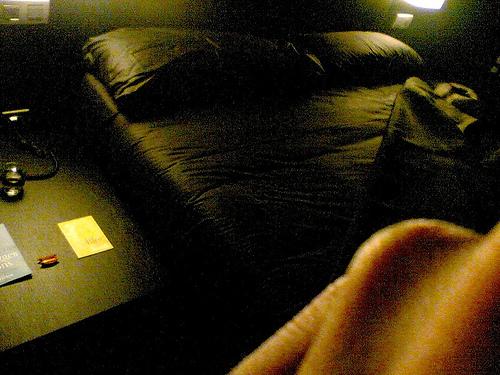Is there a bedside table?
Keep it brief. Yes. How many pillows are on the bed?
Be succinct. 2. Is the sheets orange?
Keep it brief. No. 